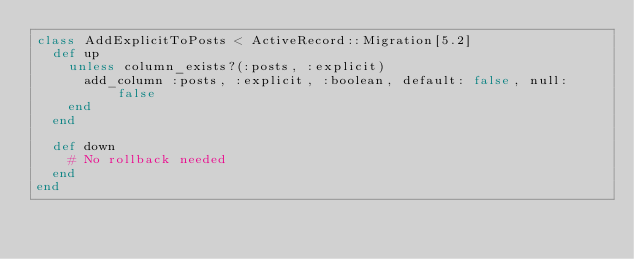Convert code to text. <code><loc_0><loc_0><loc_500><loc_500><_Ruby_>class AddExplicitToPosts < ActiveRecord::Migration[5.2]
  def up
    unless column_exists?(:posts, :explicit)
      add_column :posts, :explicit, :boolean, default: false, null: false
    end
  end

  def down
    # No rollback needed
  end
end
</code> 